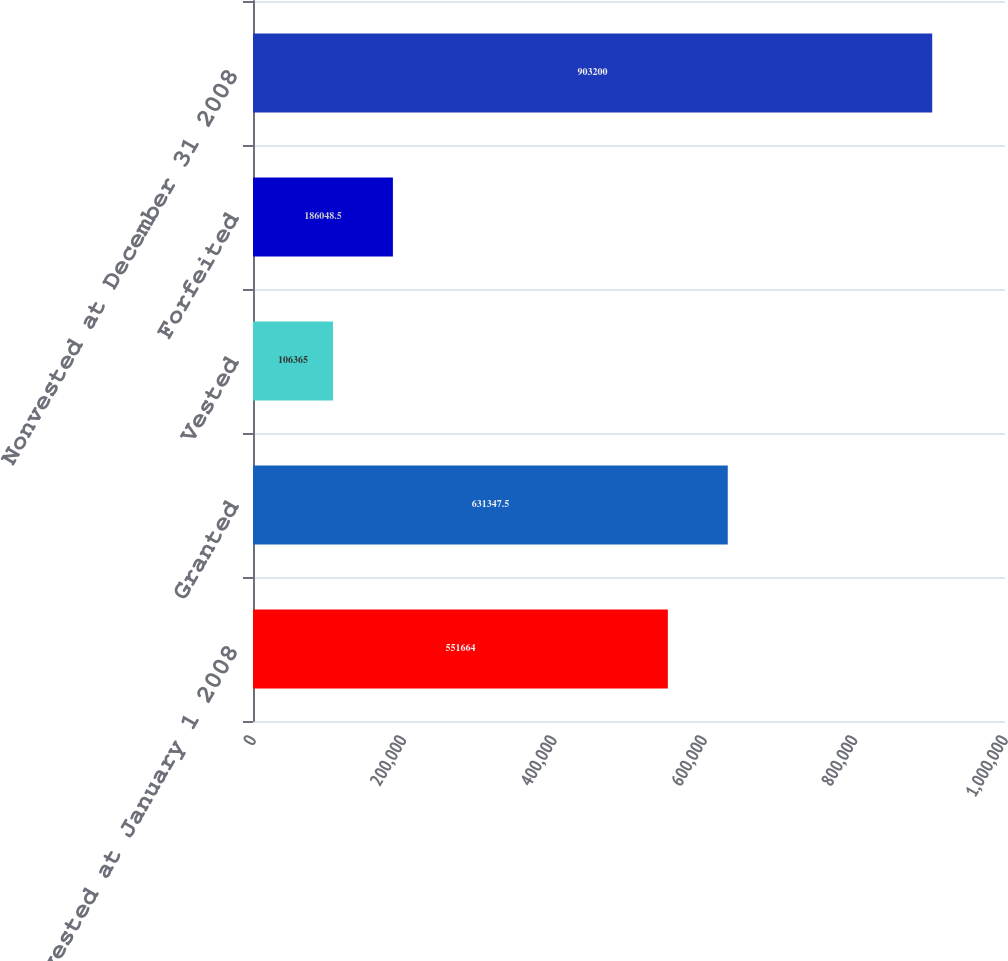Convert chart to OTSL. <chart><loc_0><loc_0><loc_500><loc_500><bar_chart><fcel>Nonvested at January 1 2008<fcel>Granted<fcel>Vested<fcel>Forfeited<fcel>Nonvested at December 31 2008<nl><fcel>551664<fcel>631348<fcel>106365<fcel>186048<fcel>903200<nl></chart> 